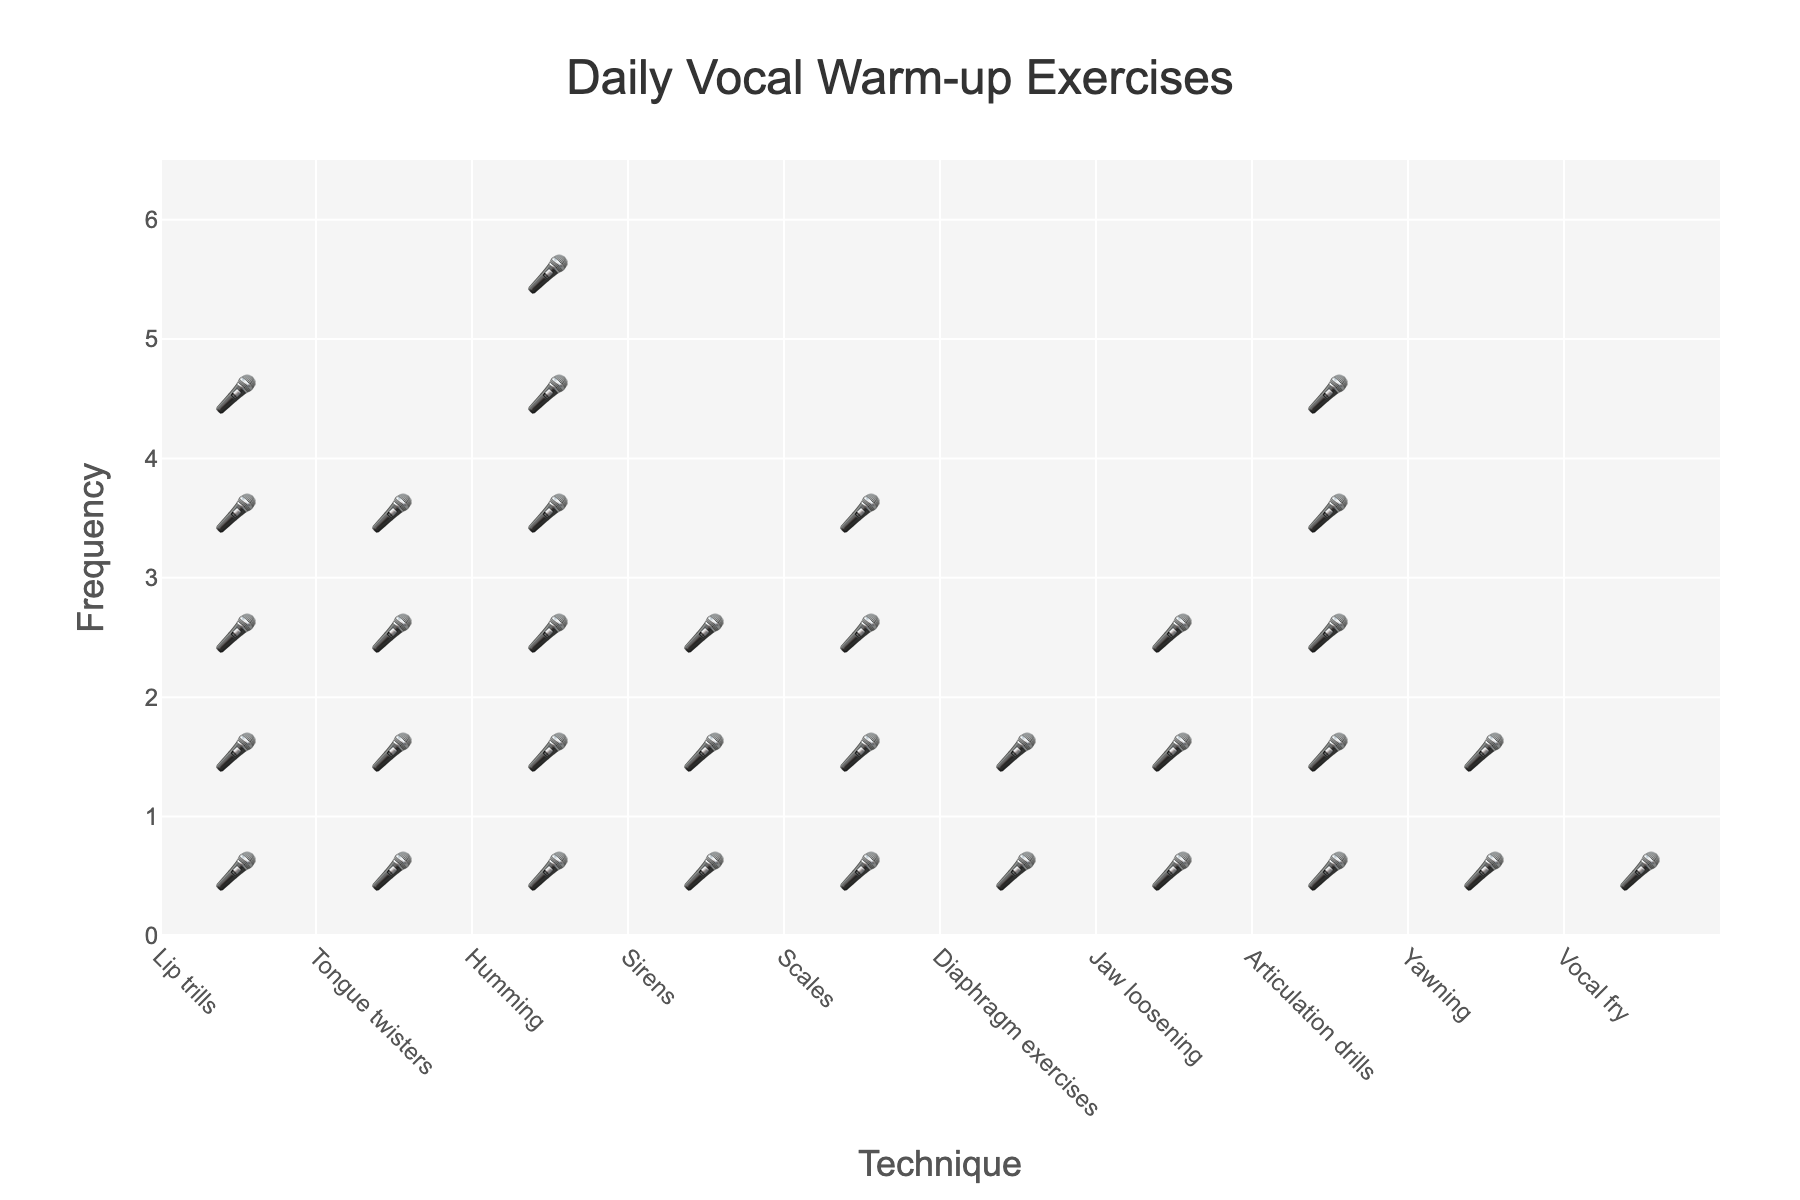what's the title of the plot? The plot title is typically displayed at the top of the figure in a larger font. In this case, it reads "Daily Vocal Warm-up Exercises".
Answer: Daily Vocal Warm-up Exercises What's the frequency of the most practiced vocal warm-up technique? To determine this, look for the technique with the highest number of repeated icons representing frequency. "Humming" has 6 icons.
Answer: 6 Which technique is the least practiced? Find the technique with the fewest number of icons representing frequency. "Vocal fry" has only 1 icon, making it the least practiced.
Answer: Vocal fry What techniques have a frequency of 4? To answer this, identify the techniques that have exactly 4 icons representing frequency. "Tongue twisters" and "Scales" both have 4 icons.
Answer: Tongue twisters, Scales What is the total number of vocal warm-up exercises practiced per day? Sum the frequencies of all techniques. The sum is 5 + 4 + 6 + 3 + 4 + 2 + 3 + 5 + 2 + 1 = 35.
Answer: 35 Which technique is practiced more frequently: Lip trills or Jaw loosening? Compare the number of icons representing frequency between "Lip trills" and "Jaw loosening". "Lip trills" has 5 and "Jaw loosening" has 3, so "Lip trills" is practiced more frequently.
Answer: Lip trills What's the frequency range of the vocal warm-up techniques? Determine the range by subtracting the minimum frequency from the maximum. The maximum frequency is 6 (Humming) and the minimum is 1 (Vocal fry). So, the range is 6 - 1.
Answer: 5 How many techniques have a frequency of 3 or more? Count the number of techniques that have at least 3 icons. The techniques are "Lip trills", "Tongue twisters", "Humming", "Sirens", "Scales", "Jaw loosening", and "Articulation drills". That's 7 techniques.
Answer: 7 Which technique's frequency is exactly half of Humming's frequency? Humming has a frequency of 6, so half of that is 3. The techniques with a frequency of 3 are "Sirens" and "Jaw loosening".
Answer: Sirens, Jaw loosening What's the average frequency of all techniques? Calculate the average by summing the frequencies and dividing by the number of techniques. The total frequency is 35, and there are 10 techniques. So, the average is 35 / 10.
Answer: 3.5 